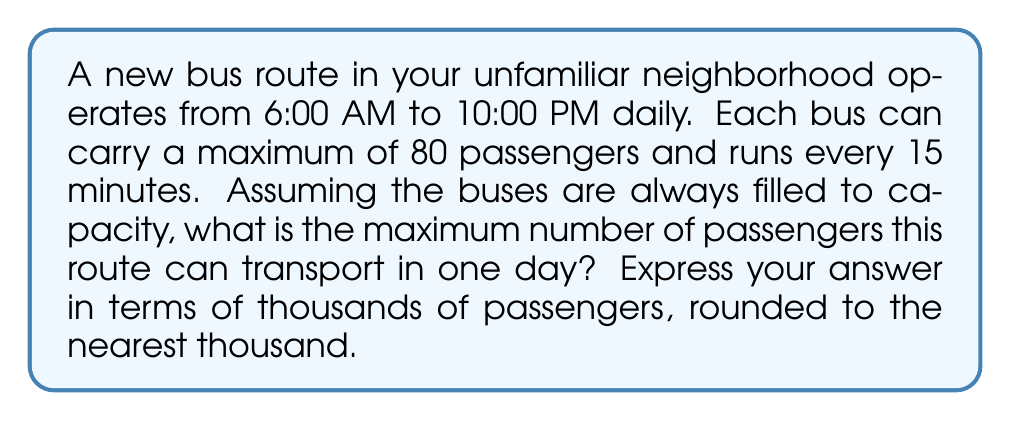Can you solve this math problem? Let's approach this step-by-step:

1) First, we need to calculate how many hours the bus route operates per day:
   10:00 PM - 6:00 AM = 16 hours

2) Now, let's determine how many buses run in one hour:
   Since a bus runs every 15 minutes, there are 4 buses per hour.
   $$ \text{Buses per hour} = \frac{60 \text{ minutes}}{15 \text{ minutes}} = 4 $$

3) Next, we calculate the total number of bus trips in a day:
   $$ \text{Total trips} = 16 \text{ hours} \times 4 \text{ trips/hour} = 64 \text{ trips} $$

4) Each bus can carry 80 passengers, so we multiply this by the number of trips:
   $$ \text{Total passengers} = 64 \text{ trips} \times 80 \text{ passengers/trip} = 5,120 \text{ passengers} $$

5) The question asks for the answer in thousands, rounded to the nearest thousand:
   5,120 ≈ 5,000

Therefore, the maximum capacity of this bus route is approximately 5,000 passengers per day.
Answer: 5 thousand passengers 